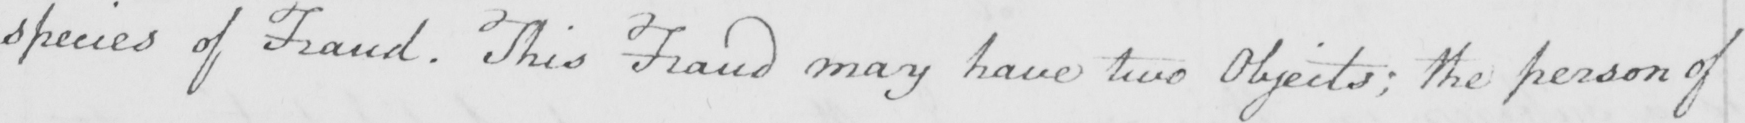Can you read and transcribe this handwriting? species of fraud . This Fraud may have two Objects ; the person of 